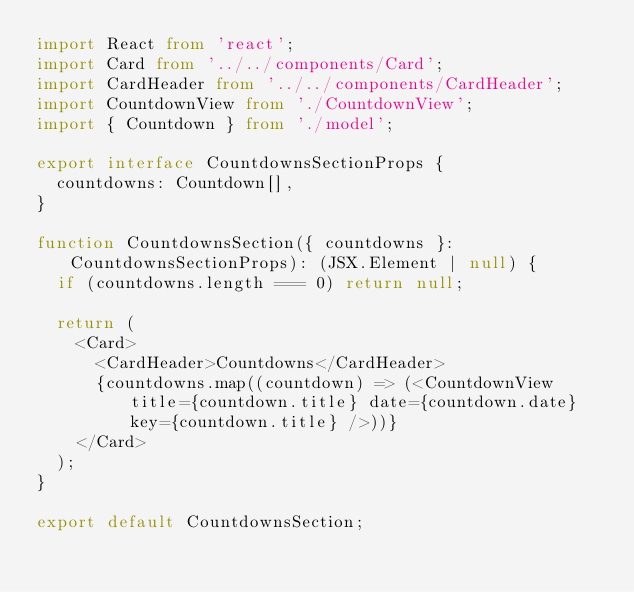<code> <loc_0><loc_0><loc_500><loc_500><_TypeScript_>import React from 'react';
import Card from '../../components/Card';
import CardHeader from '../../components/CardHeader';
import CountdownView from './CountdownView';
import { Countdown } from './model';

export interface CountdownsSectionProps {
  countdowns: Countdown[],
}

function CountdownsSection({ countdowns }: CountdownsSectionProps): (JSX.Element | null) {
  if (countdowns.length === 0) return null;

  return (
    <Card>
      <CardHeader>Countdowns</CardHeader>
      {countdowns.map((countdown) => (<CountdownView title={countdown.title} date={countdown.date} key={countdown.title} />))}
    </Card>
  );
}

export default CountdownsSection;
</code> 